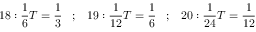<formula> <loc_0><loc_0><loc_500><loc_500>1 8 \colon { \frac { 1 } { 6 } } T = { \frac { 1 } { 3 } } \, ; \, 1 9 \colon { \frac { 1 } { 1 2 } } T = { \frac { 1 } { 6 } } \, ; \, 2 0 \colon { \frac { 1 } { 2 4 } } T = { \frac { 1 } { 1 2 } }</formula> 